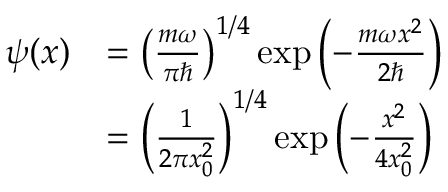Convert formula to latex. <formula><loc_0><loc_0><loc_500><loc_500>{ \begin{array} { r l } { \psi ( x ) } & { = \left ( { \frac { m \omega } { \pi } } \right ) ^ { 1 / 4 } \exp { \left ( - { \frac { m \omega x ^ { 2 } } { 2 } } \right ) } } \\ & { = \left ( { \frac { 1 } { 2 \pi x _ { 0 } ^ { 2 } } } \right ) ^ { 1 / 4 } \exp { \left ( - { \frac { x ^ { 2 } } { 4 x _ { 0 } ^ { 2 } } } \right ) } } \end{array} }</formula> 